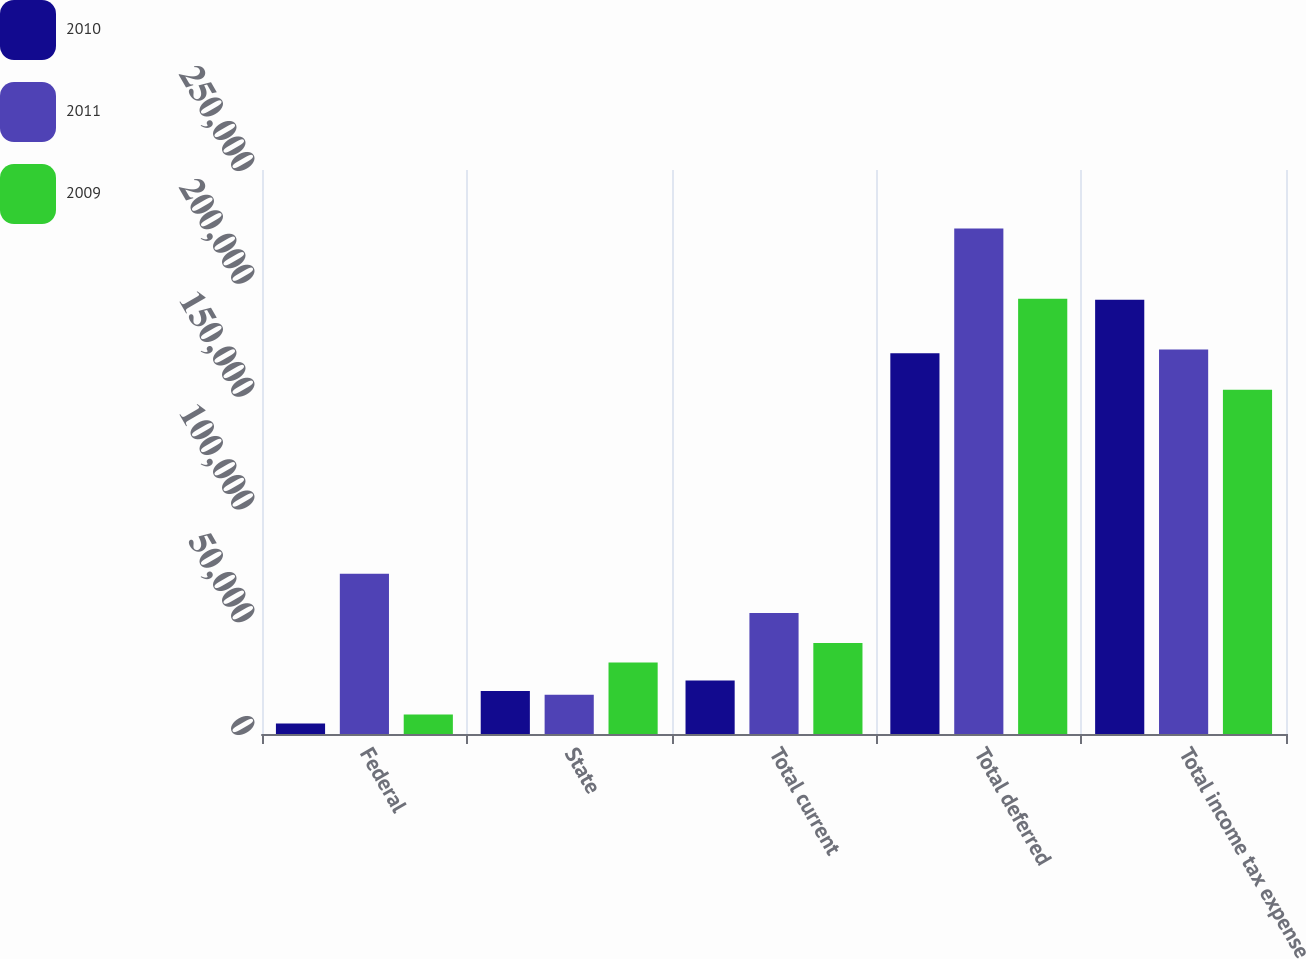<chart> <loc_0><loc_0><loc_500><loc_500><stacked_bar_chart><ecel><fcel>Federal<fcel>State<fcel>Total current<fcel>Total deferred<fcel>Total income tax expense<nl><fcel>2010<fcel>4633<fcel>19104<fcel>23737<fcel>168805<fcel>192542<nl><fcel>2011<fcel>71036<fcel>17406<fcel>53630<fcel>224095<fcel>170465<nl><fcel>2009<fcel>8667<fcel>31673<fcel>40340<fcel>192914<fcel>152574<nl></chart> 